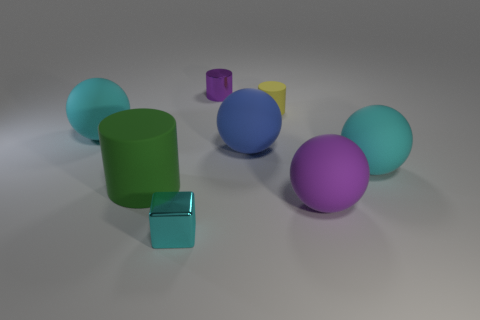Is there any other thing that has the same color as the small block?
Ensure brevity in your answer.  Yes. What number of things are either yellow rubber things or rubber things that are on the left side of the large purple thing?
Provide a succinct answer. 4. There is a small cylinder that is on the right side of the blue thing behind the purple thing on the right side of the tiny yellow thing; what is it made of?
Provide a short and direct response. Rubber. The blue thing that is the same material as the large green cylinder is what size?
Ensure brevity in your answer.  Large. What color is the large sphere to the left of the tiny shiny thing that is in front of the small yellow rubber cylinder?
Give a very brief answer. Cyan. What number of blocks have the same material as the purple cylinder?
Keep it short and to the point. 1. How many rubber objects are big blocks or big blue objects?
Provide a succinct answer. 1. What is the material of the purple thing that is the same size as the blue matte ball?
Give a very brief answer. Rubber. Is there a large purple object made of the same material as the large green cylinder?
Ensure brevity in your answer.  Yes. There is a big purple thing behind the small thing in front of the big cyan thing to the left of the purple cylinder; what is its shape?
Ensure brevity in your answer.  Sphere. 